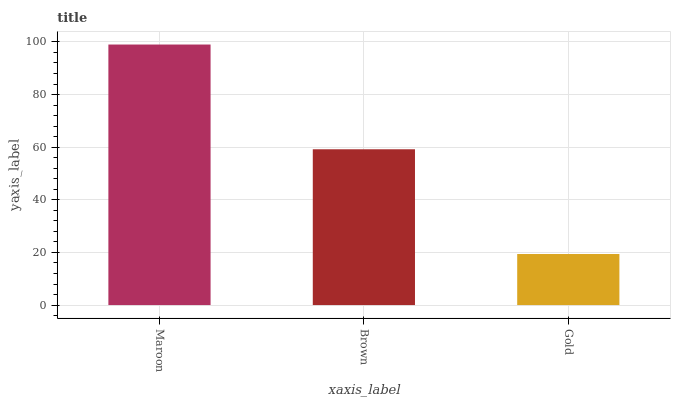Is Gold the minimum?
Answer yes or no. Yes. Is Maroon the maximum?
Answer yes or no. Yes. Is Brown the minimum?
Answer yes or no. No. Is Brown the maximum?
Answer yes or no. No. Is Maroon greater than Brown?
Answer yes or no. Yes. Is Brown less than Maroon?
Answer yes or no. Yes. Is Brown greater than Maroon?
Answer yes or no. No. Is Maroon less than Brown?
Answer yes or no. No. Is Brown the high median?
Answer yes or no. Yes. Is Brown the low median?
Answer yes or no. Yes. Is Maroon the high median?
Answer yes or no. No. Is Maroon the low median?
Answer yes or no. No. 